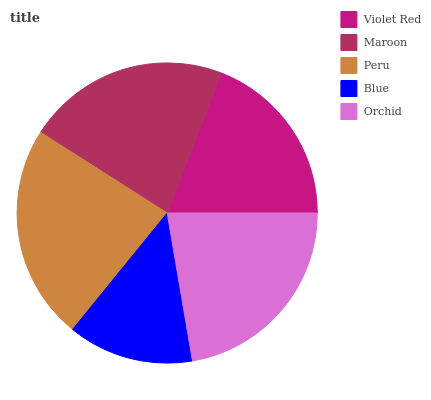Is Blue the minimum?
Answer yes or no. Yes. Is Peru the maximum?
Answer yes or no. Yes. Is Maroon the minimum?
Answer yes or no. No. Is Maroon the maximum?
Answer yes or no. No. Is Maroon greater than Violet Red?
Answer yes or no. Yes. Is Violet Red less than Maroon?
Answer yes or no. Yes. Is Violet Red greater than Maroon?
Answer yes or no. No. Is Maroon less than Violet Red?
Answer yes or no. No. Is Maroon the high median?
Answer yes or no. Yes. Is Maroon the low median?
Answer yes or no. Yes. Is Violet Red the high median?
Answer yes or no. No. Is Peru the low median?
Answer yes or no. No. 